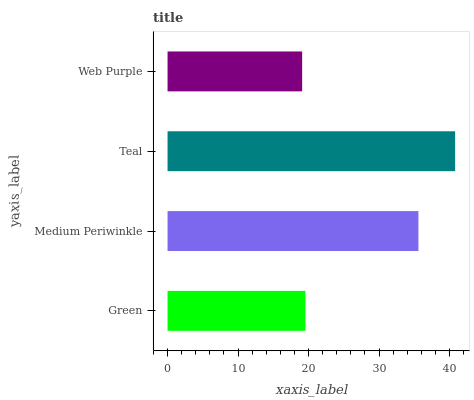Is Web Purple the minimum?
Answer yes or no. Yes. Is Teal the maximum?
Answer yes or no. Yes. Is Medium Periwinkle the minimum?
Answer yes or no. No. Is Medium Periwinkle the maximum?
Answer yes or no. No. Is Medium Periwinkle greater than Green?
Answer yes or no. Yes. Is Green less than Medium Periwinkle?
Answer yes or no. Yes. Is Green greater than Medium Periwinkle?
Answer yes or no. No. Is Medium Periwinkle less than Green?
Answer yes or no. No. Is Medium Periwinkle the high median?
Answer yes or no. Yes. Is Green the low median?
Answer yes or no. Yes. Is Green the high median?
Answer yes or no. No. Is Medium Periwinkle the low median?
Answer yes or no. No. 